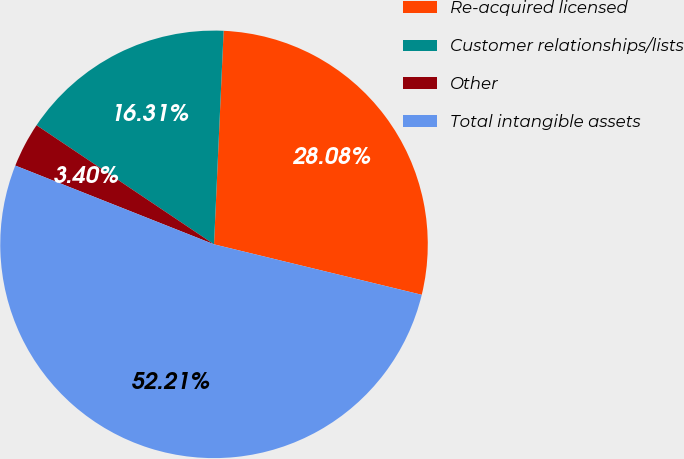Convert chart. <chart><loc_0><loc_0><loc_500><loc_500><pie_chart><fcel>Re-acquired licensed<fcel>Customer relationships/lists<fcel>Other<fcel>Total intangible assets<nl><fcel>28.08%<fcel>16.31%<fcel>3.4%<fcel>52.22%<nl></chart> 